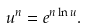Convert formula to latex. <formula><loc_0><loc_0><loc_500><loc_500>u ^ { n } = e ^ { n \ln u } .</formula> 